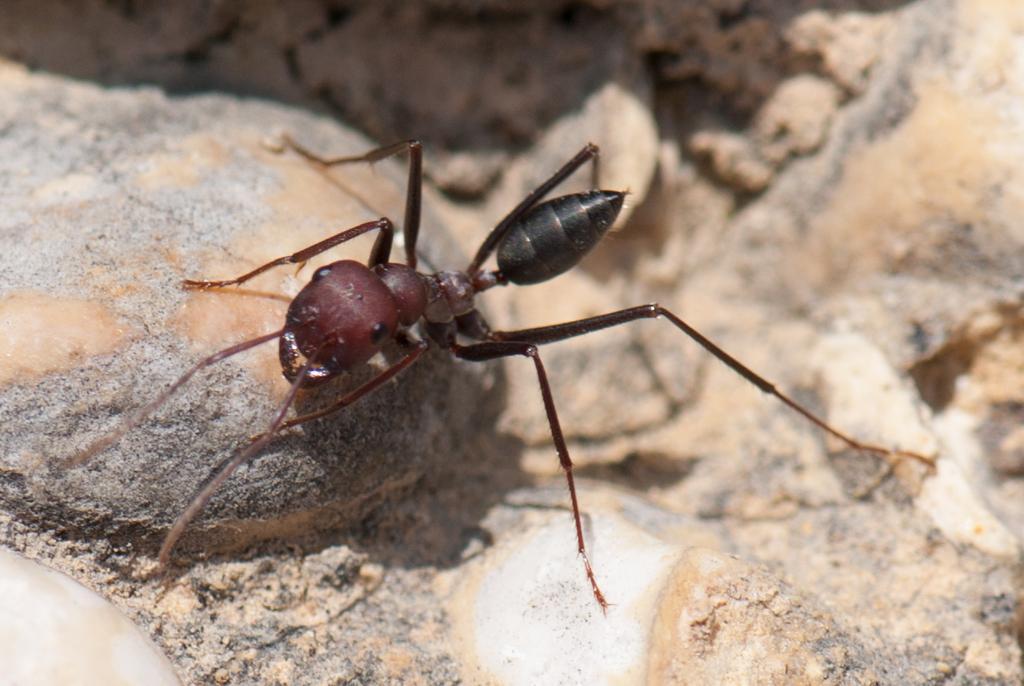Can you describe this image briefly? In this picture we can see an ant and in the background we can see few stones. 